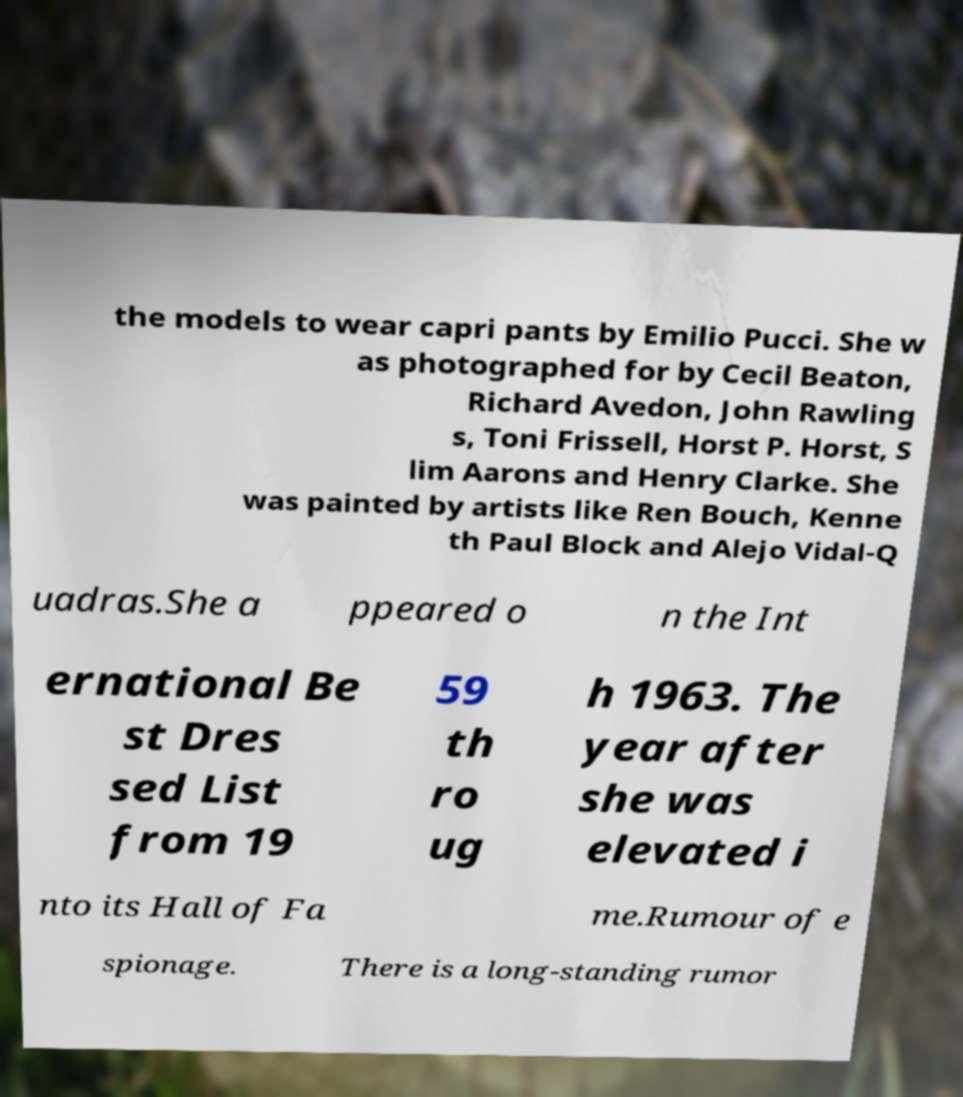What messages or text are displayed in this image? I need them in a readable, typed format. the models to wear capri pants by Emilio Pucci. She w as photographed for by Cecil Beaton, Richard Avedon, John Rawling s, Toni Frissell, Horst P. Horst, S lim Aarons and Henry Clarke. She was painted by artists like Ren Bouch, Kenne th Paul Block and Alejo Vidal-Q uadras.She a ppeared o n the Int ernational Be st Dres sed List from 19 59 th ro ug h 1963. The year after she was elevated i nto its Hall of Fa me.Rumour of e spionage. There is a long-standing rumor 